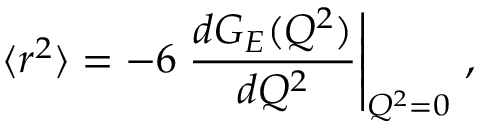<formula> <loc_0><loc_0><loc_500><loc_500>\langle r ^ { 2 } \rangle = - 6 { \frac { d G _ { E } ( Q ^ { 2 } ) } { d Q ^ { 2 } } } \right | _ { Q ^ { 2 } = 0 } \, ,</formula> 